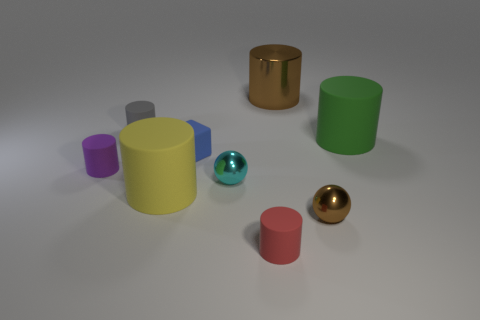Do the tiny matte object behind the big green matte cylinder and the tiny shiny sphere in front of the cyan sphere have the same color?
Give a very brief answer. No. What color is the matte block that is the same size as the red cylinder?
Provide a short and direct response. Blue. Is there a cube of the same color as the large shiny cylinder?
Offer a very short reply. No. There is a metallic ball behind the brown metal sphere; is its size the same as the big brown metallic object?
Give a very brief answer. No. Are there the same number of blue things that are in front of the brown metallic sphere and large purple balls?
Make the answer very short. Yes. What number of objects are either rubber cylinders that are to the left of the yellow cylinder or blue things?
Give a very brief answer. 3. There is a small thing that is both in front of the purple matte cylinder and on the left side of the red thing; what is its shape?
Offer a terse response. Sphere. How many objects are either small objects in front of the small purple matte cylinder or tiny gray rubber things in front of the brown cylinder?
Offer a very short reply. 4. What number of other objects are there of the same size as the rubber cube?
Ensure brevity in your answer.  5. There is a large matte object right of the rubber block; is its color the same as the tiny cube?
Keep it short and to the point. No. 